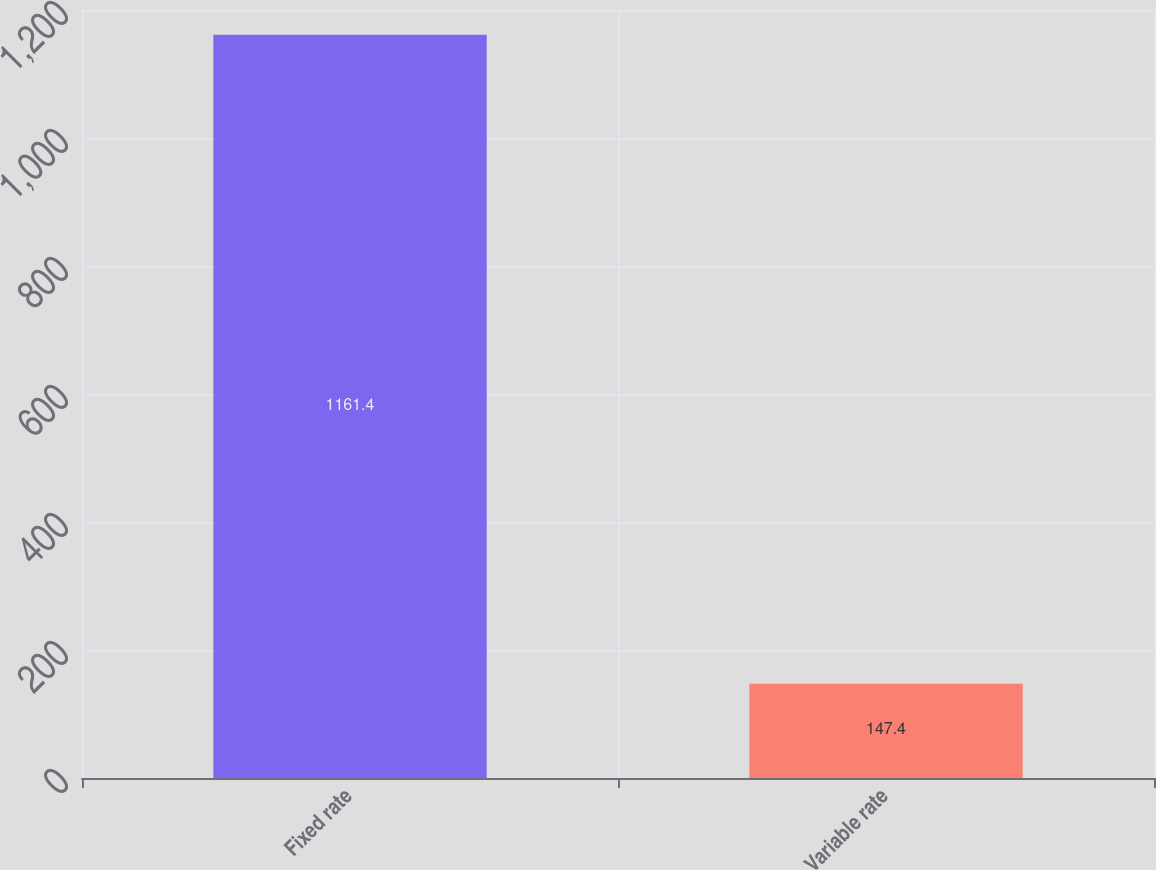<chart> <loc_0><loc_0><loc_500><loc_500><bar_chart><fcel>Fixed rate<fcel>Variable rate<nl><fcel>1161.4<fcel>147.4<nl></chart> 